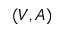Convert formula to latex. <formula><loc_0><loc_0><loc_500><loc_500>( V , A )</formula> 